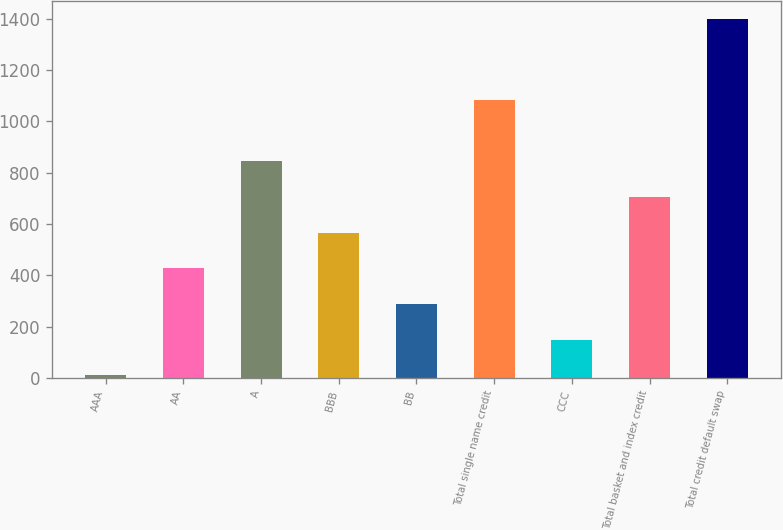<chart> <loc_0><loc_0><loc_500><loc_500><bar_chart><fcel>AAA<fcel>AA<fcel>A<fcel>BBB<fcel>BB<fcel>Total single name credit<fcel>CCC<fcel>Total basket and index credit<fcel>Total credit default swap<nl><fcel>10<fcel>426.97<fcel>843.94<fcel>565.96<fcel>287.98<fcel>1084.9<fcel>148.99<fcel>704.95<fcel>1399.9<nl></chart> 